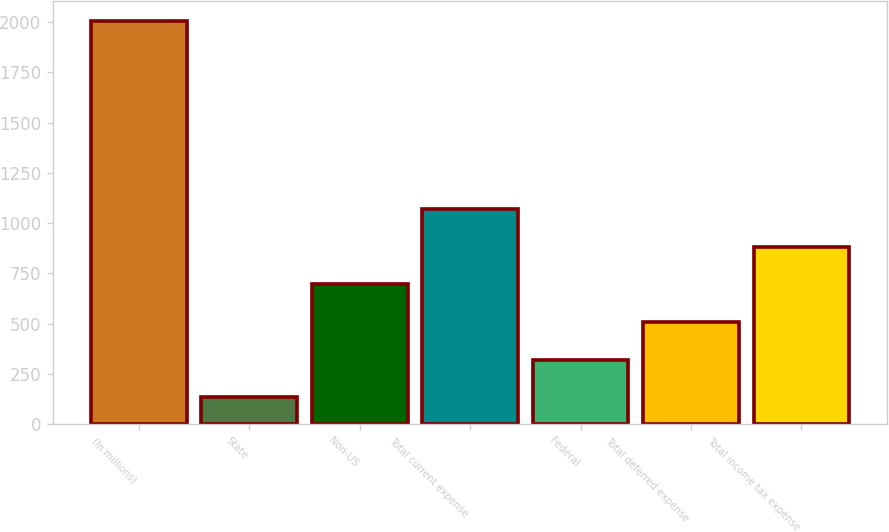<chart> <loc_0><loc_0><loc_500><loc_500><bar_chart><fcel>(In millions)<fcel>State<fcel>Non-US<fcel>Total current expense<fcel>Federal<fcel>Total deferred expense<fcel>Total income tax expense<nl><fcel>2007<fcel>133<fcel>695.2<fcel>1070<fcel>320.4<fcel>507.8<fcel>882.6<nl></chart> 